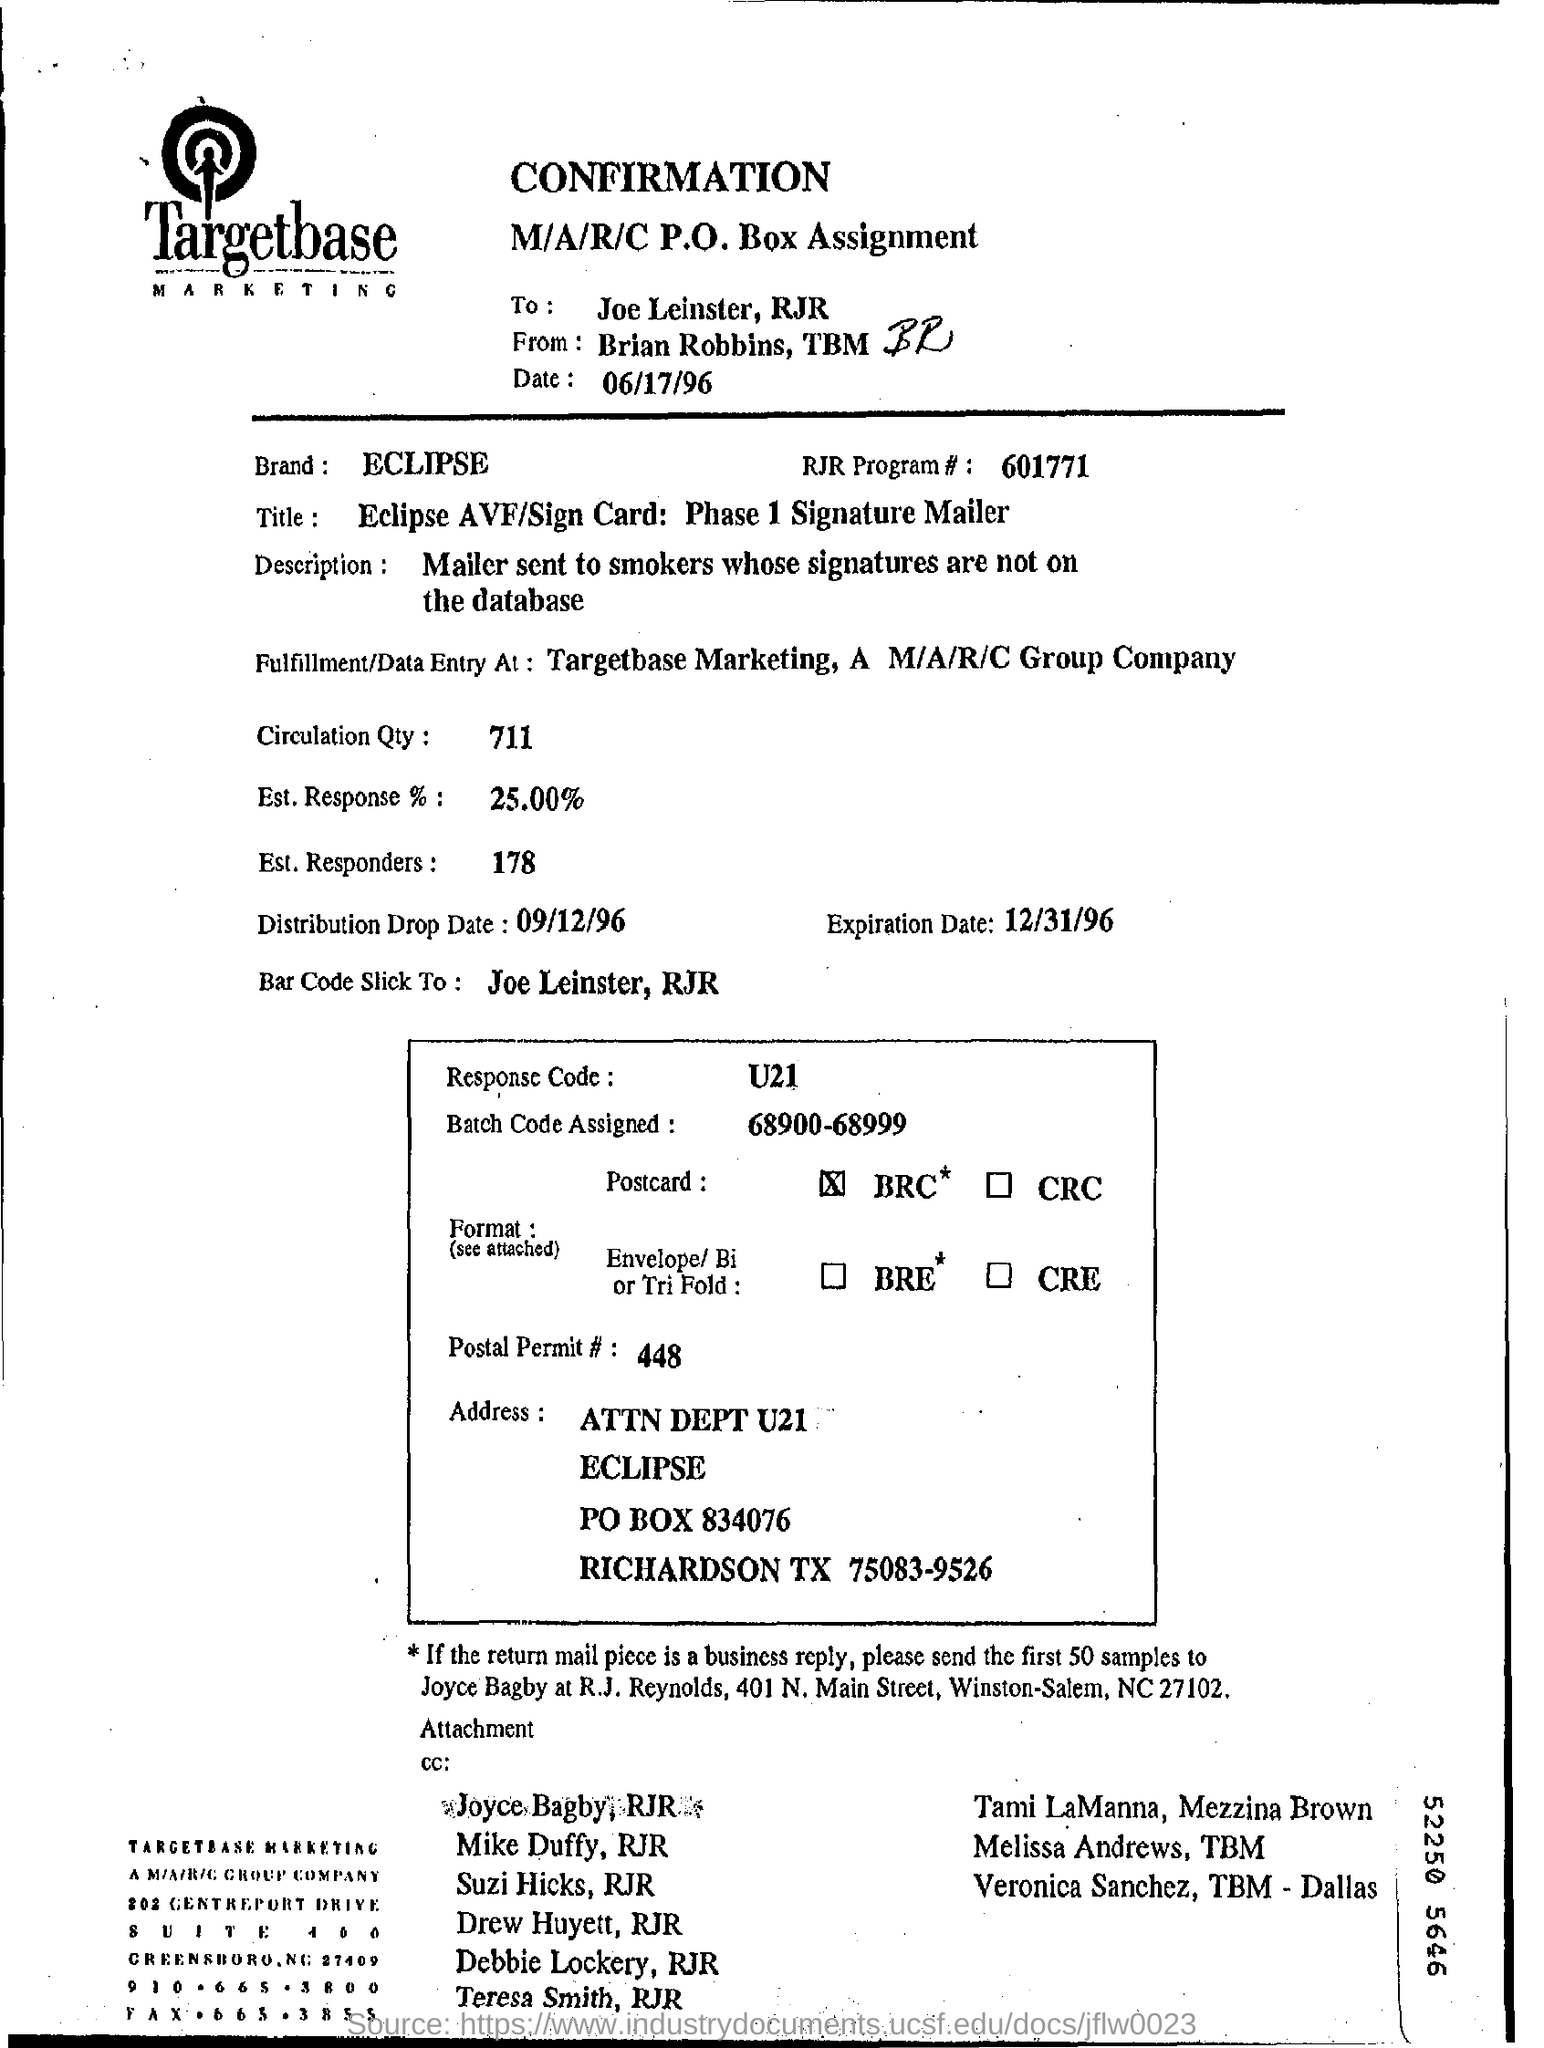To whom, the document is addressed?
Provide a succinct answer. Joe Leinster, RJR. Which Brand is mentioned in this document?
Offer a very short reply. ECLIPSE. What is the Response Code mentioned in the document?
Give a very brief answer. U21. What is  the Batch Code assigned?
Provide a succinct answer. 68900-68999. What is the Distribution Drop Date mentioned in the document?
Offer a very short reply. 09/12/96. What is RJR Program # no?
Ensure brevity in your answer.  601771. What is the Circulation Qty as per the document?
Give a very brief answer. 711. What is the Est. Response %  as per the document?
Give a very brief answer. 25.00%. 